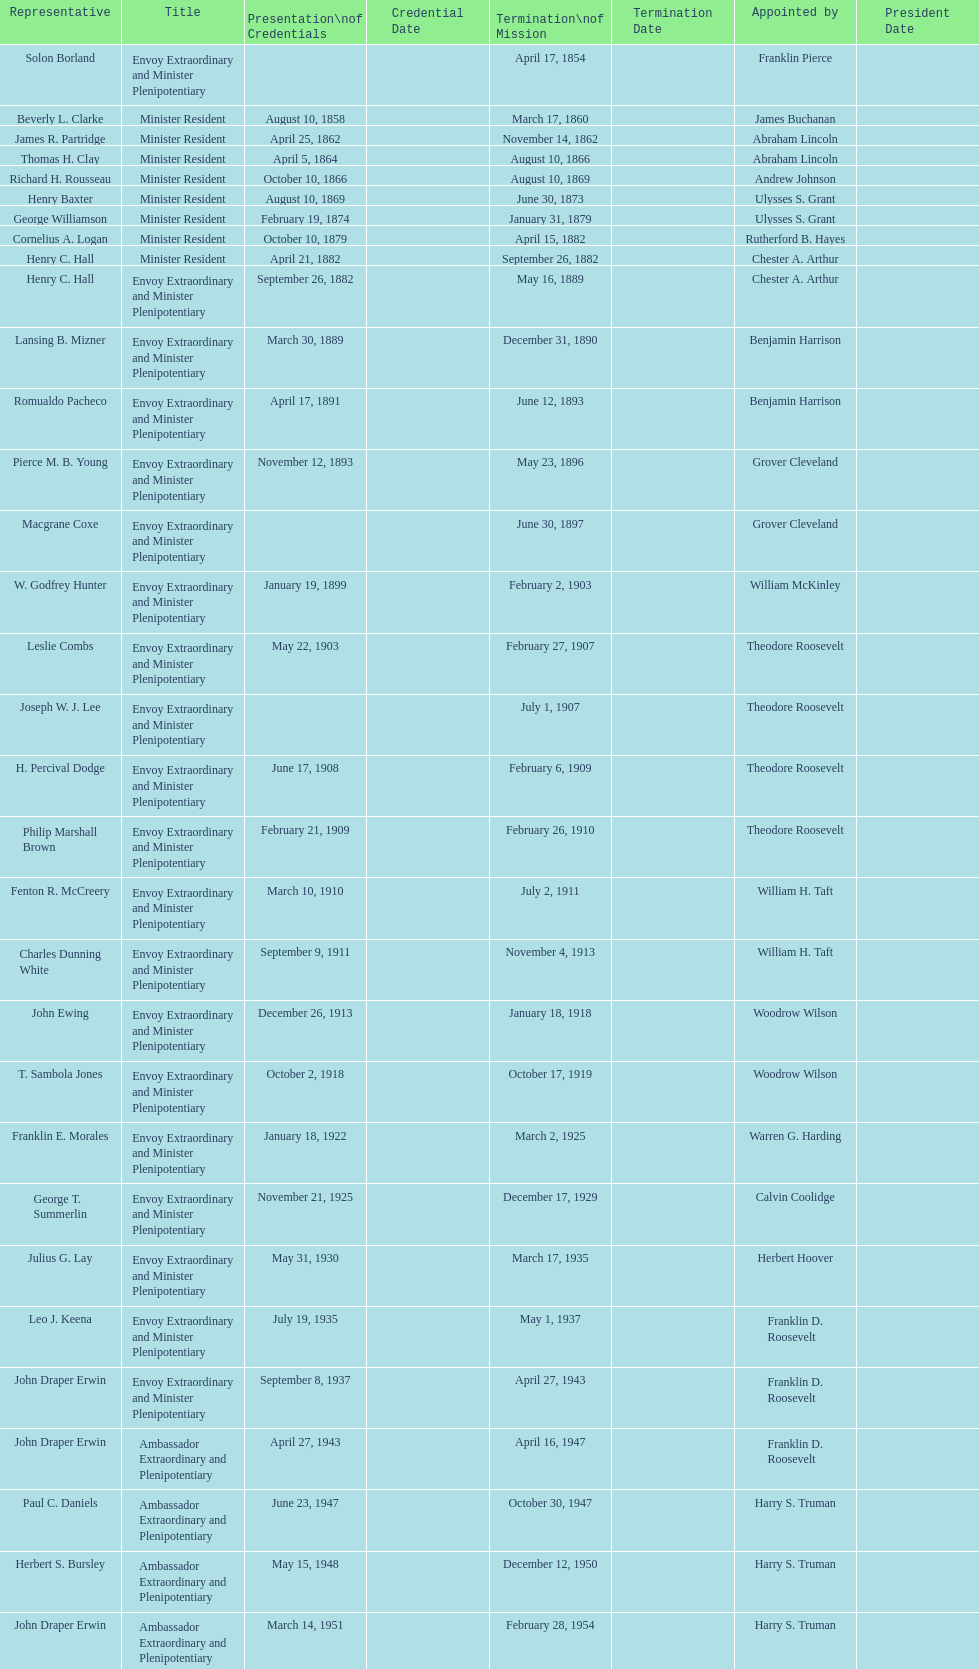Which reps were only appointed by franklin pierce? Solon Borland. 